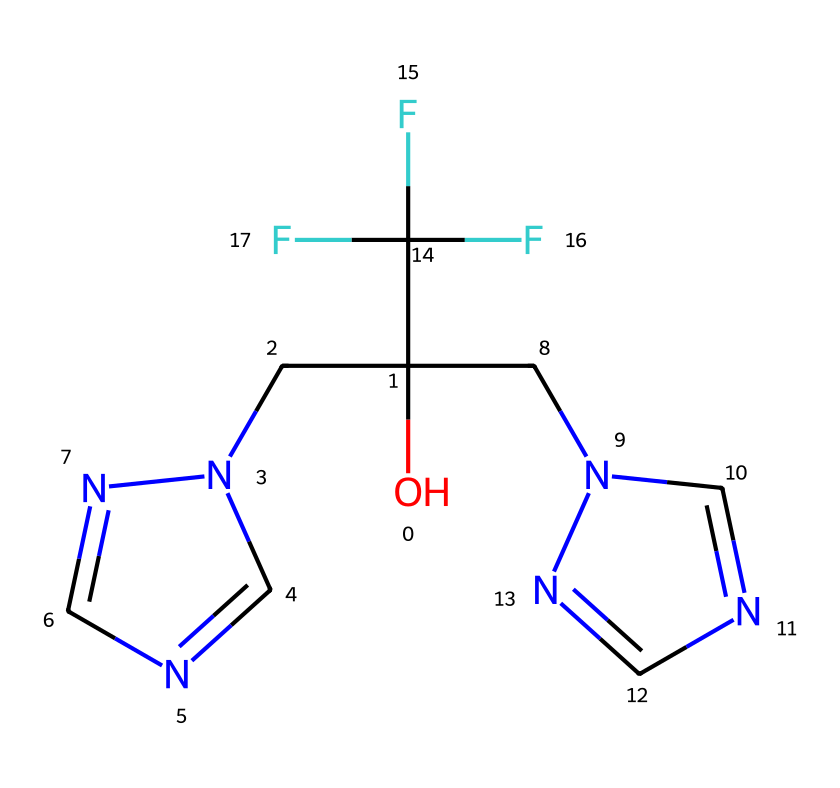What is the molecular formula of fluconazole? To find the molecular formula, count the number of atoms of each element in the SMILES representation. There are: 13 carbon (C), 13 hydrogen (H), 4 nitrogen (N), 2 oxygen (O), and 3 fluorine (F) atoms. Thus, the molecular formula is C13H13F3N4O2.
Answer: C13H13F3N4O2 How many carbon atoms are present in fluconazole? By examining the SMILES notation, you can identify the number of carbon (C) atoms. There are 13 carbon atoms present in the structure.
Answer: 13 What functional groups are present in fluconazole? Analyze the SMILES structure for functional groups. The presence of the hydroxyl group (-OH) indicates alcohol, while the triazole rings indicate the presence of nitrogen-containing heterocycles. Hence, fluconazole contains a hydroxyl group and triazole functional groups.
Answer: hydroxyl and triazole Is fluconazole a broad-spectrum antifungal agent? Fluconazole is known to be a broad-spectrum antifungal medication, effective against a wide range of fungal pathogens. This classification is based on its mechanism of action and the diversity of pathogens it can treat.
Answer: yes How many nitrogen atoms are in fluconazole? Count the nitrogen (N) atoms in the SMILES structure. The analysis shows there are 4 nitrogen atoms in the chemical's structure.
Answer: 4 What characteristic feature does the trifluoromethyl group provide to fluconazole? The trifluoromethyl group (CF3) in the structure introduces increased lipophilicity and potential bioactivity, affecting the solubility and interaction of the drug within biological membranes. This contributes to fluconazole's efficacy as an antifungal agent.
Answer: lipophilicity 